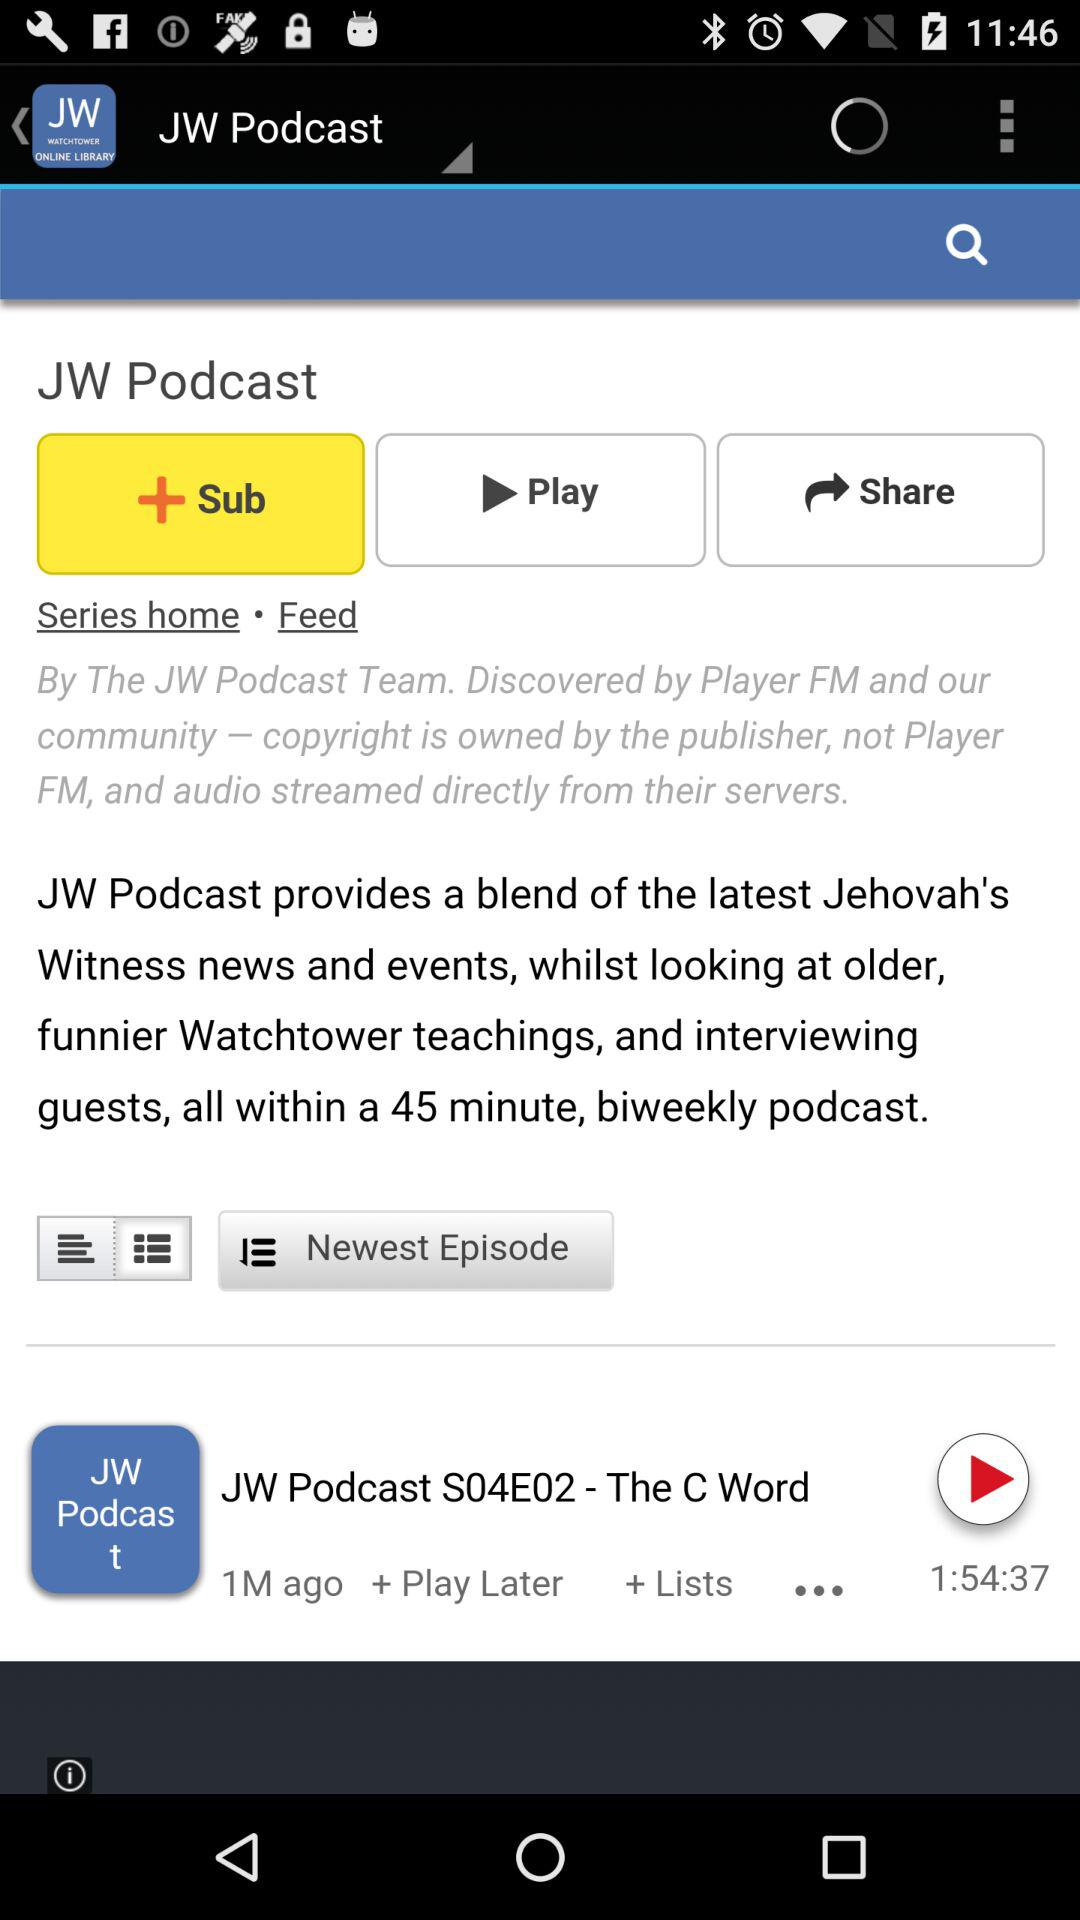Which season is currently playing? The season currently playing is 4. 